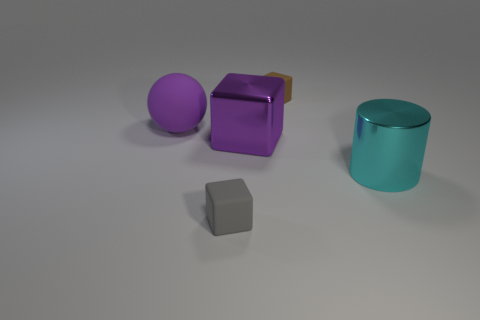There is a big object that is the same color as the large rubber sphere; what is its shape?
Provide a succinct answer. Cube. Are there more large purple matte objects behind the large purple sphere than tiny yellow matte cylinders?
Ensure brevity in your answer.  No. Is there a purple shiny block?
Give a very brief answer. Yes. Is the color of the large cylinder the same as the rubber sphere?
Offer a very short reply. No. How many small objects are either brown objects or gray objects?
Provide a short and direct response. 2. Is there anything else that is the same color as the large block?
Keep it short and to the point. Yes. There is a small gray object that is made of the same material as the tiny brown thing; what shape is it?
Make the answer very short. Cube. What is the size of the rubber object on the left side of the gray object?
Make the answer very short. Large. The small gray object is what shape?
Ensure brevity in your answer.  Cube. There is a matte block behind the big cyan metallic thing; is its size the same as the purple thing that is right of the gray matte block?
Your response must be concise. No. 